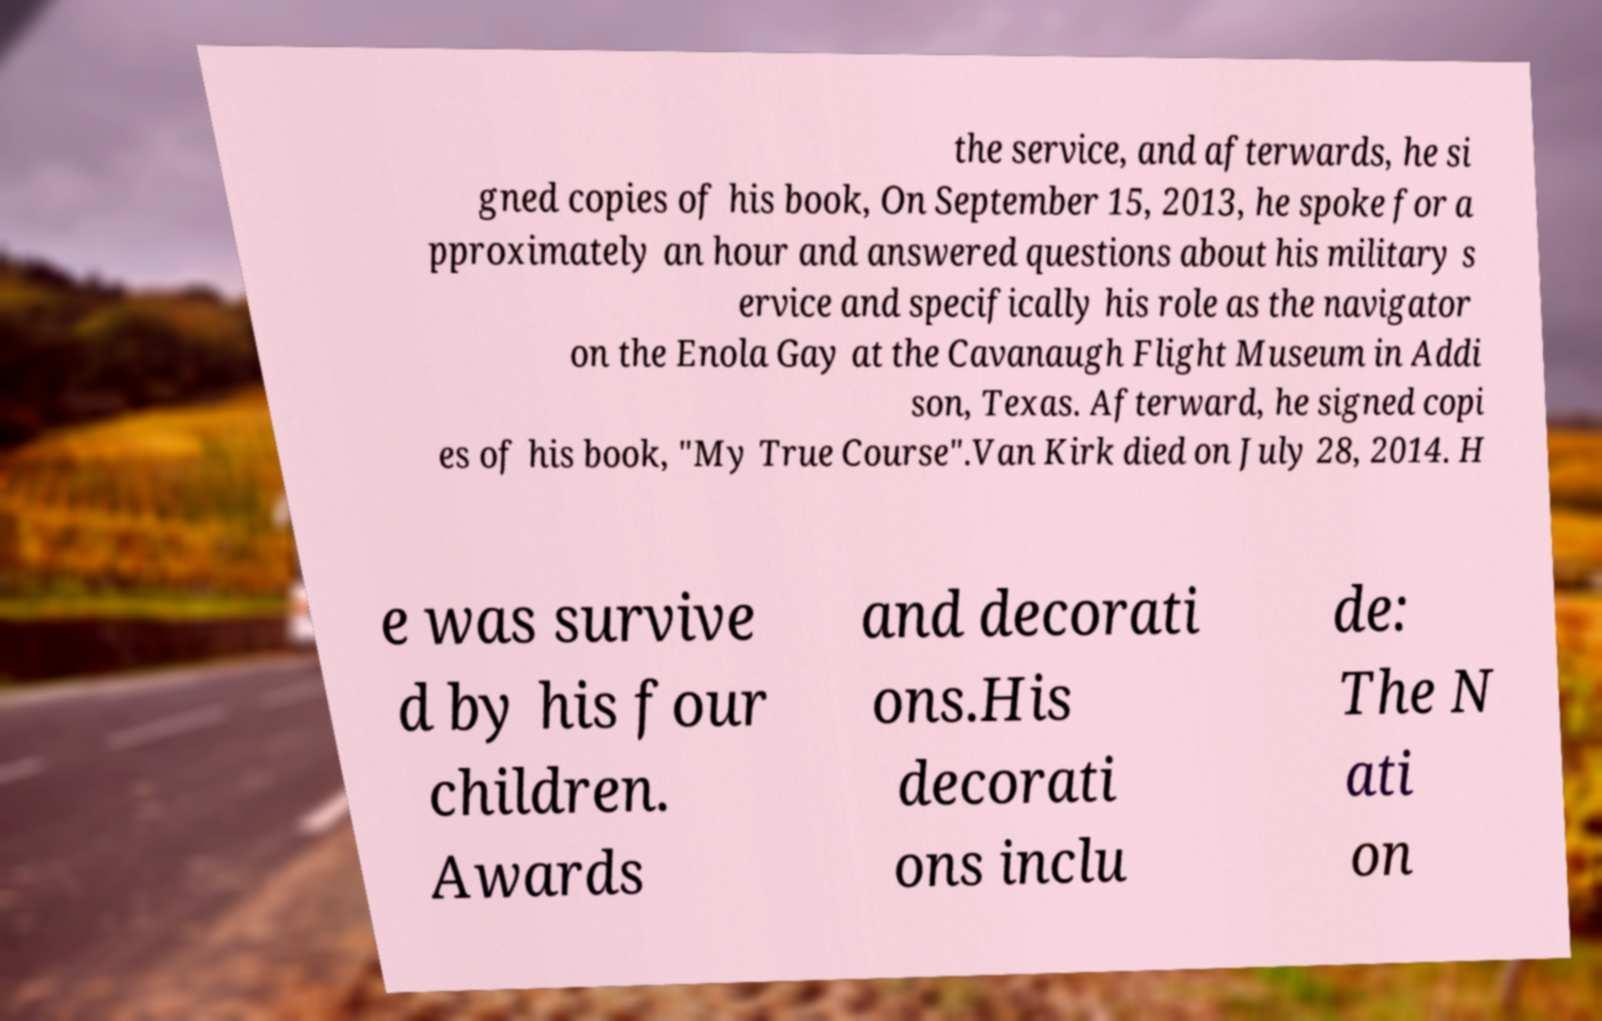Could you assist in decoding the text presented in this image and type it out clearly? the service, and afterwards, he si gned copies of his book, On September 15, 2013, he spoke for a pproximately an hour and answered questions about his military s ervice and specifically his role as the navigator on the Enola Gay at the Cavanaugh Flight Museum in Addi son, Texas. Afterward, he signed copi es of his book, "My True Course".Van Kirk died on July 28, 2014. H e was survive d by his four children. Awards and decorati ons.His decorati ons inclu de: The N ati on 